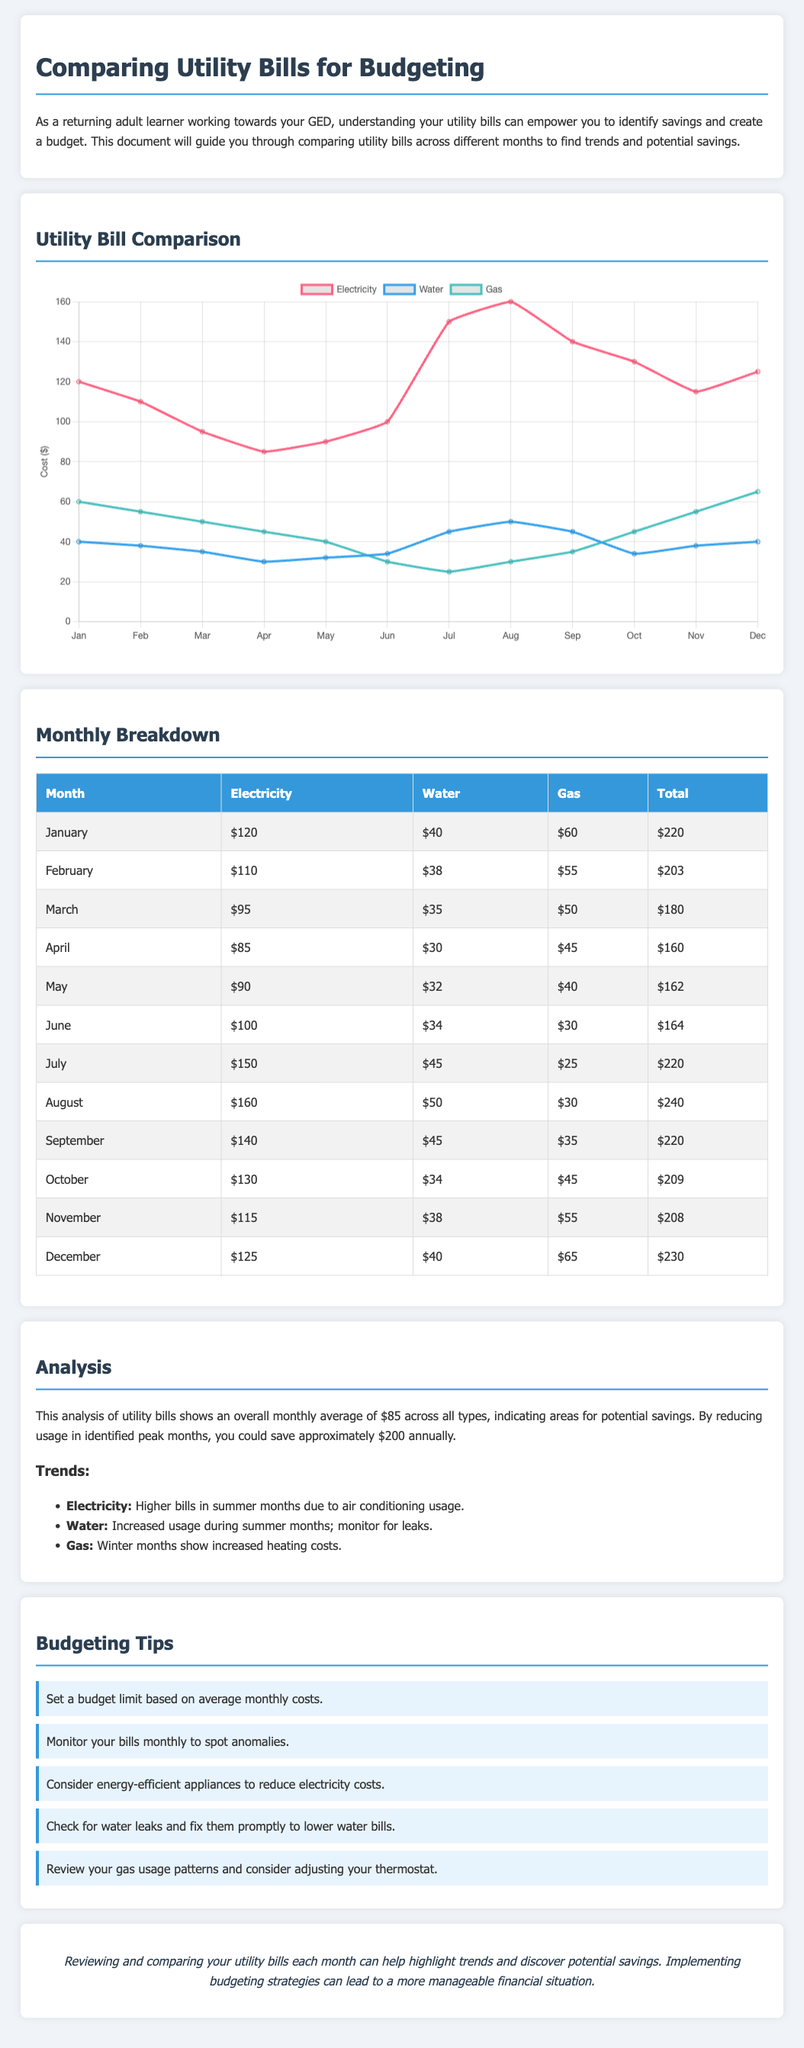What is the highest electricity bill in the year? The highest electricity bill can be identified from the monthly breakdown, which shows $160 in August.
Answer: $160 What month has the lowest total utility bill? By comparing the total bills across each month, April has the lowest total at $160.
Answer: April How much was spent on water in July? The monthly breakdown indicates that $45 was spent on water in July.
Answer: $45 What is the average monthly total across all months? The analysis states that the overall monthly average total is calculated to be $85.
Answer: $85 Which utility's usage increased during summer months according to the trends? The trends mention that electricity usage is higher in summer months due to air conditioning, indicating an increase in electricity costs.
Answer: Electricity What is one suggested budgeting tip mentioned in the document? The document lists several tips, one being to monitor your bills monthly to spot anomalies.
Answer: Monitor your bills monthly What was the gas cost in December? The monthly breakdown shows that the gas cost in December was $65.
Answer: $65 Which month shows the lowest water bill? The water bill is lowest in April, recorded at $30 in the monthly breakdown.
Answer: April What is the total utility bill for October? According to the data, the total utility bill for October is $209.
Answer: $209 